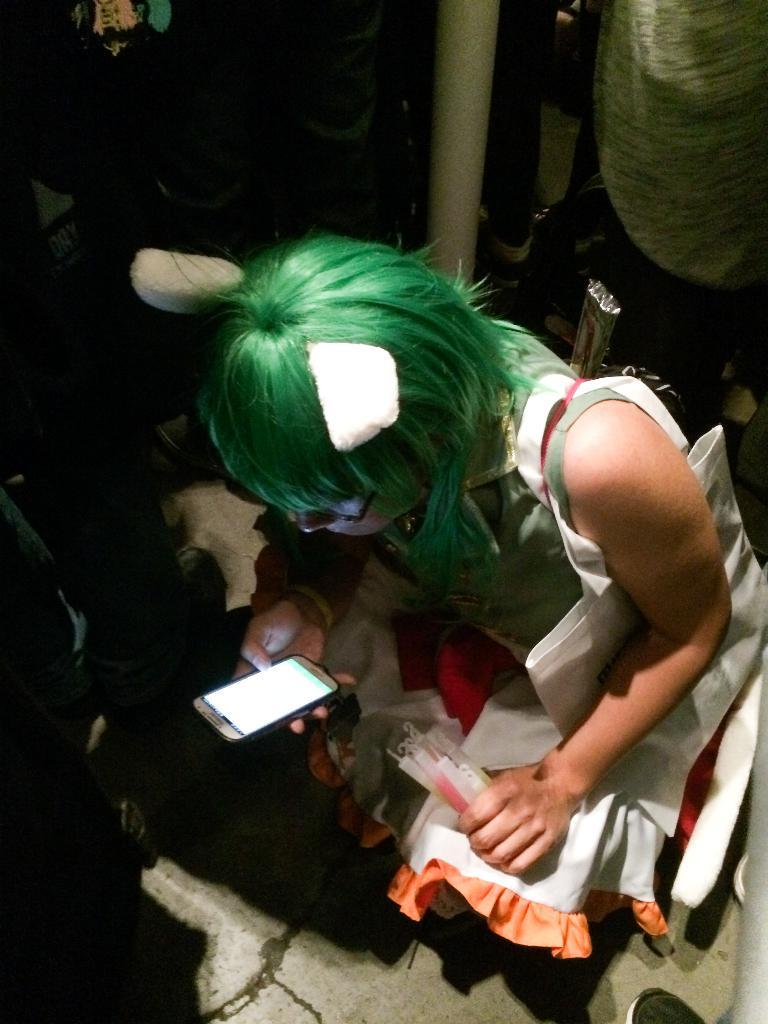Who is present in the image? There is a woman in the image. What is the woman holding? The woman is holding a cellphone. What other objects can be seen in the image? There are candles and a pole in the image. Are there any other people in the image besides the woman? Yes, there is a group of people in the image. What rhythm is the woman dancing to in the image? There is no indication in the image that the woman is dancing, and therefore no rhythm can be determined. 